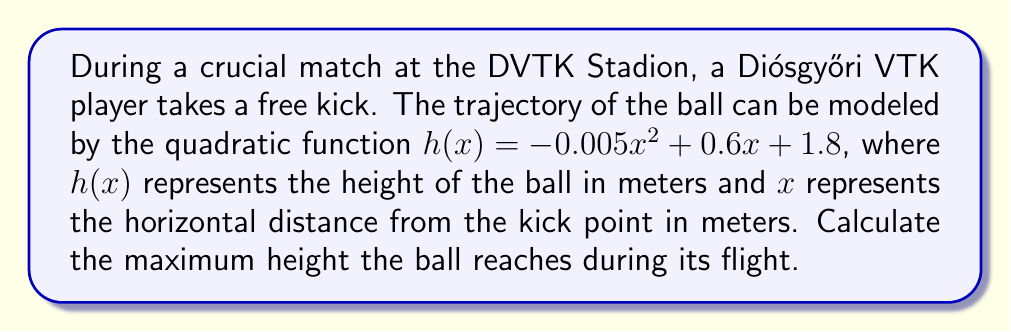Provide a solution to this math problem. To find the maximum height of the ball's trajectory, we need to determine the vertex of the parabola described by the quadratic function. The general form of a quadratic function is $f(x) = ax^2 + bx + c$, where the vertex is located at $(-\frac{b}{2a}, f(-\frac{b}{2a}))$.

Given function: $h(x) = -0.005x^2 + 0.6x + 1.8$

1. Identify $a$, $b$, and $c$:
   $a = -0.005$
   $b = 0.6$
   $c = 1.8$

2. Calculate the x-coordinate of the vertex:
   $x = -\frac{b}{2a} = -\frac{0.6}{2(-0.005)} = 60$ meters

3. Calculate the maximum height by substituting $x = 60$ into the original function:
   $$\begin{align}
   h(60) &= -0.005(60)^2 + 0.6(60) + 1.8 \\
   &= -0.005(3600) + 36 + 1.8 \\
   &= -18 + 36 + 1.8 \\
   &= 19.8
   \end{align}$$

Therefore, the maximum height reached by the ball is 19.8 meters.
Answer: The maximum height reached by the ball is 19.8 meters. 